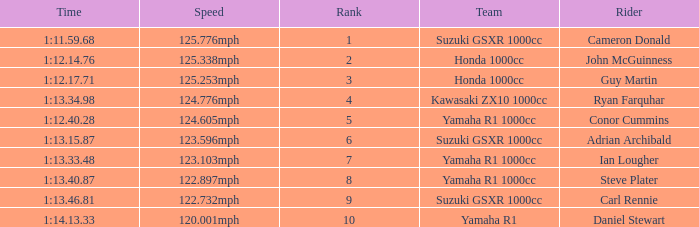Help me parse the entirety of this table. {'header': ['Time', 'Speed', 'Rank', 'Team', 'Rider'], 'rows': [['1:11.59.68', '125.776mph', '1', 'Suzuki GSXR 1000cc', 'Cameron Donald'], ['1:12.14.76', '125.338mph', '2', 'Honda 1000cc', 'John McGuinness'], ['1:12.17.71', '125.253mph', '3', 'Honda 1000cc', 'Guy Martin'], ['1:13.34.98', '124.776mph', '4', 'Kawasaki ZX10 1000cc', 'Ryan Farquhar'], ['1:12.40.28', '124.605mph', '5', 'Yamaha R1 1000cc', 'Conor Cummins'], ['1:13.15.87', '123.596mph', '6', 'Suzuki GSXR 1000cc', 'Adrian Archibald'], ['1:13.33.48', '123.103mph', '7', 'Yamaha R1 1000cc', 'Ian Lougher'], ['1:13.40.87', '122.897mph', '8', 'Yamaha R1 1000cc', 'Steve Plater'], ['1:13.46.81', '122.732mph', '9', 'Suzuki GSXR 1000cc', 'Carl Rennie'], ['1:14.13.33', '120.001mph', '10', 'Yamaha R1', 'Daniel Stewart']]} What is the rank for the team with a Time of 1:12.40.28? 5.0. 